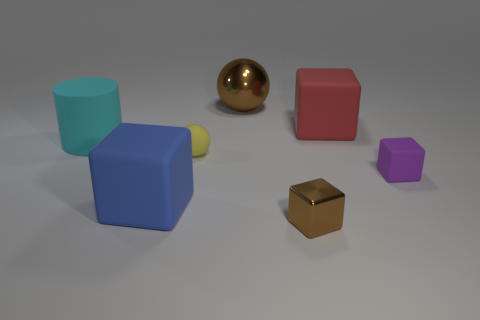How many blocks are small cyan objects or big red things?
Provide a succinct answer. 1. There is a tiny brown object that is the same shape as the small purple rubber thing; what is its material?
Your response must be concise. Metal. There is a blue thing that is made of the same material as the tiny yellow object; what is its size?
Give a very brief answer. Large. Is the shape of the metallic thing to the left of the brown block the same as the small object that is right of the big red cube?
Ensure brevity in your answer.  No. The other tiny thing that is made of the same material as the yellow thing is what color?
Make the answer very short. Purple. Is the size of the brown thing in front of the blue matte thing the same as the ball that is in front of the red matte object?
Keep it short and to the point. Yes. What is the shape of the big rubber object that is to the right of the large cyan thing and to the left of the large ball?
Give a very brief answer. Cube. Are there any red blocks made of the same material as the small purple object?
Provide a succinct answer. Yes. Is the material of the big thing on the right side of the brown metal sphere the same as the block that is to the left of the yellow matte ball?
Offer a very short reply. Yes. Are there more large metal spheres than big yellow shiny blocks?
Your answer should be compact. Yes. 